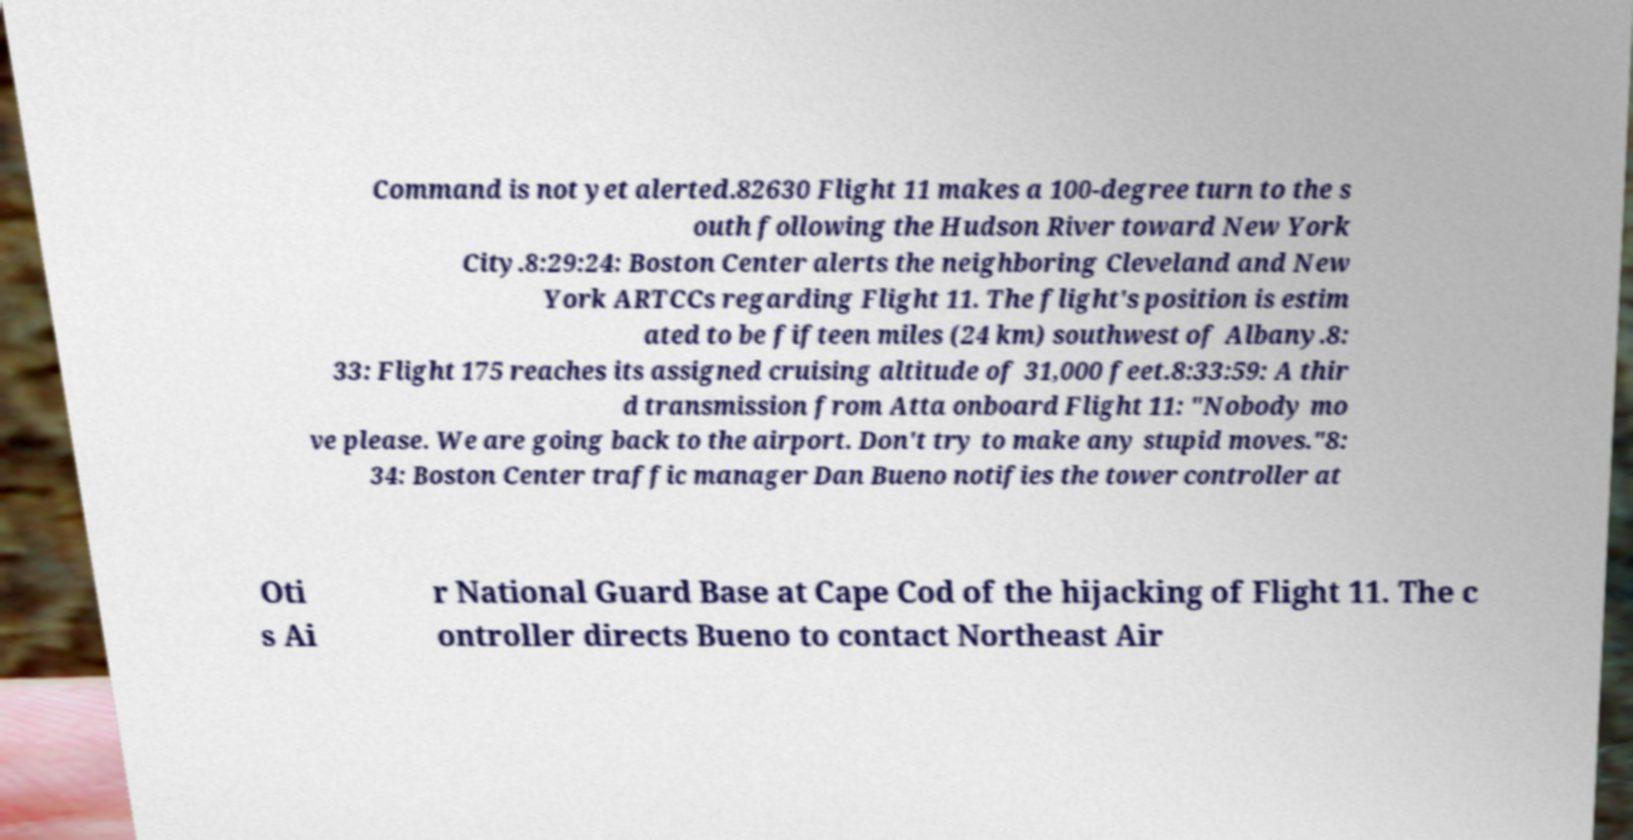Can you read and provide the text displayed in the image?This photo seems to have some interesting text. Can you extract and type it out for me? Command is not yet alerted.82630 Flight 11 makes a 100-degree turn to the s outh following the Hudson River toward New York City.8:29:24: Boston Center alerts the neighboring Cleveland and New York ARTCCs regarding Flight 11. The flight's position is estim ated to be fifteen miles (24 km) southwest of Albany.8: 33: Flight 175 reaches its assigned cruising altitude of 31,000 feet.8:33:59: A thir d transmission from Atta onboard Flight 11: "Nobody mo ve please. We are going back to the airport. Don't try to make any stupid moves."8: 34: Boston Center traffic manager Dan Bueno notifies the tower controller at Oti s Ai r National Guard Base at Cape Cod of the hijacking of Flight 11. The c ontroller directs Bueno to contact Northeast Air 